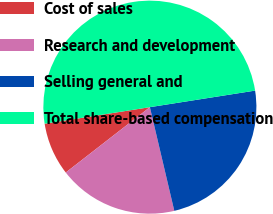Convert chart. <chart><loc_0><loc_0><loc_500><loc_500><pie_chart><fcel>Cost of sales<fcel>Research and development<fcel>Selling general and<fcel>Total share-based compensation<nl><fcel>8.03%<fcel>18.17%<fcel>23.8%<fcel>50.0%<nl></chart> 